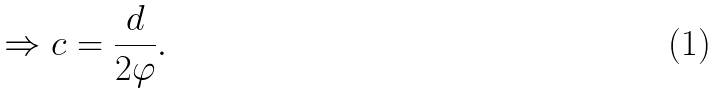<formula> <loc_0><loc_0><loc_500><loc_500>\Rightarrow c = { \frac { d } { 2 \varphi } } .</formula> 